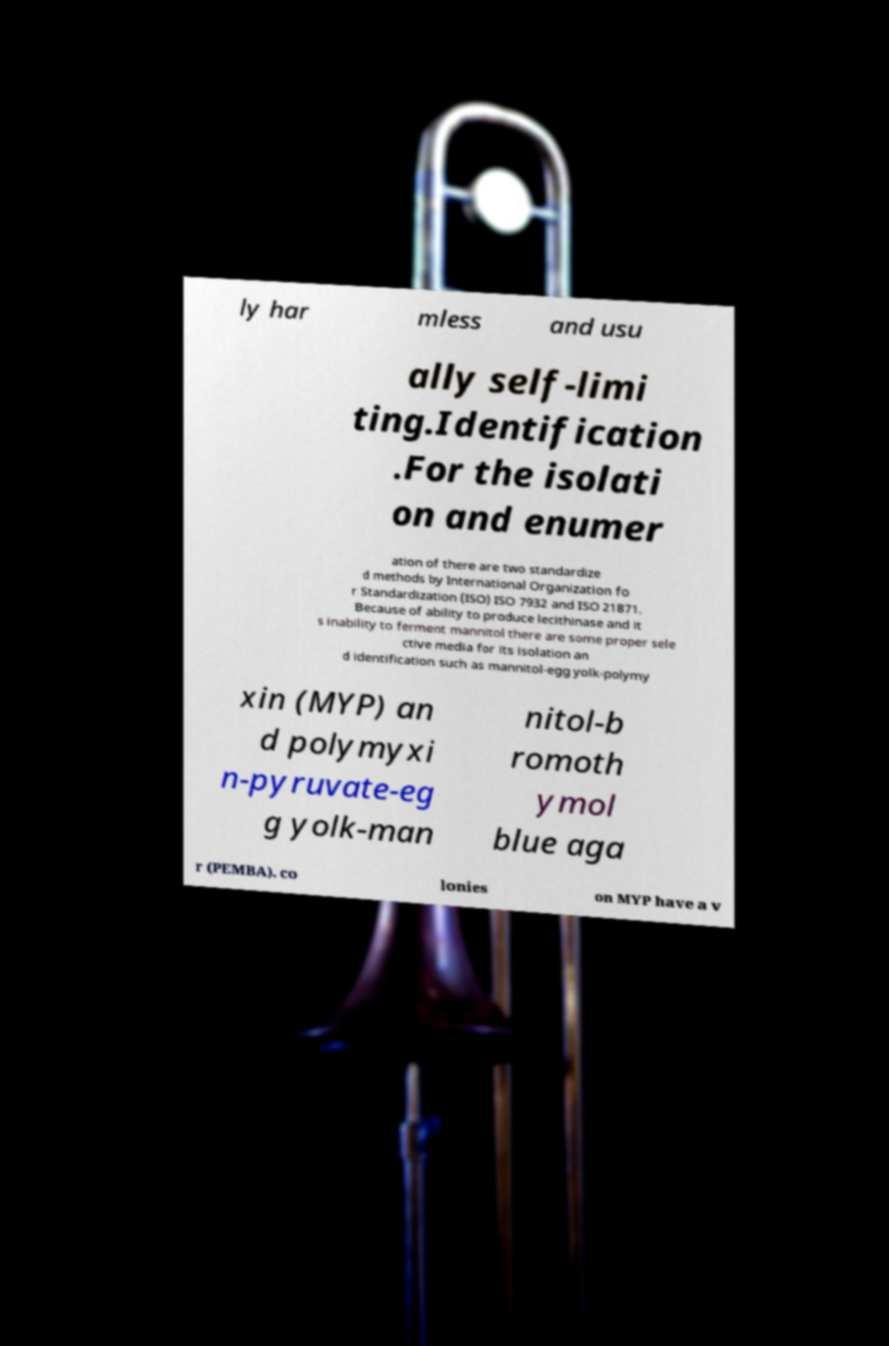I need the written content from this picture converted into text. Can you do that? ly har mless and usu ally self-limi ting.Identification .For the isolati on and enumer ation of there are two standardize d methods by International Organization fo r Standardization (ISO) ISO 7932 and ISO 21871. Because of ability to produce lecithinase and it s inability to ferment mannitol there are some proper sele ctive media for its isolation an d identification such as mannitol-egg yolk-polymy xin (MYP) an d polymyxi n-pyruvate-eg g yolk-man nitol-b romoth ymol blue aga r (PEMBA). co lonies on MYP have a v 